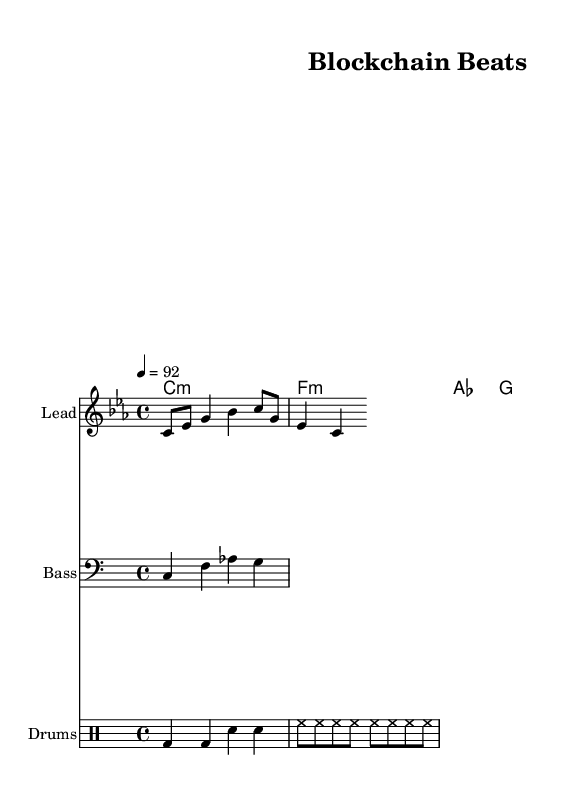What is the key signature of this music? The key signature is C minor, which has three flats: B flat, E flat, and A flat. This can be identified by looking at the signature at the beginning of the staff.
Answer: C minor What is the time signature of this music? The time signature is 4/4, which indicates four beats in a measure and a quarter note gets one beat. This is visible as the fraction notated at the beginning of the staff.
Answer: 4/4 What is the tempo marking of this piece? The tempo marking is 92 beats per minute, noted at the beginning of the score. It indicates the speed at which the music should be played.
Answer: 92 What instruments are featured in this music? The score features a lead instrument, bass, and drums, as indicated by the instrument names provided above each staff.
Answer: Lead, Bass, Drums How many measures are in the melody? The melody consists of 2 measures, which can be counted by identifying the vertical bar lines separating different measures in the sheet music.
Answer: 2 How does the harmony relate to the melody? The harmony consists of four chords: C minor, F minor, A flat major, and G major, which provide the tonal support for the melody. The chords are played in harmony with the melody throughout the piece.
Answer: Supports melody What is the significance of the drums in this rap piece? The drums maintain the rhythm and drive of the rap, providing a foundational groove that complements the vocal rhythms commonly found in hip-hop. The drum pattern established a consistent beat throughout the piece.
Answer: Establishes rhythm 